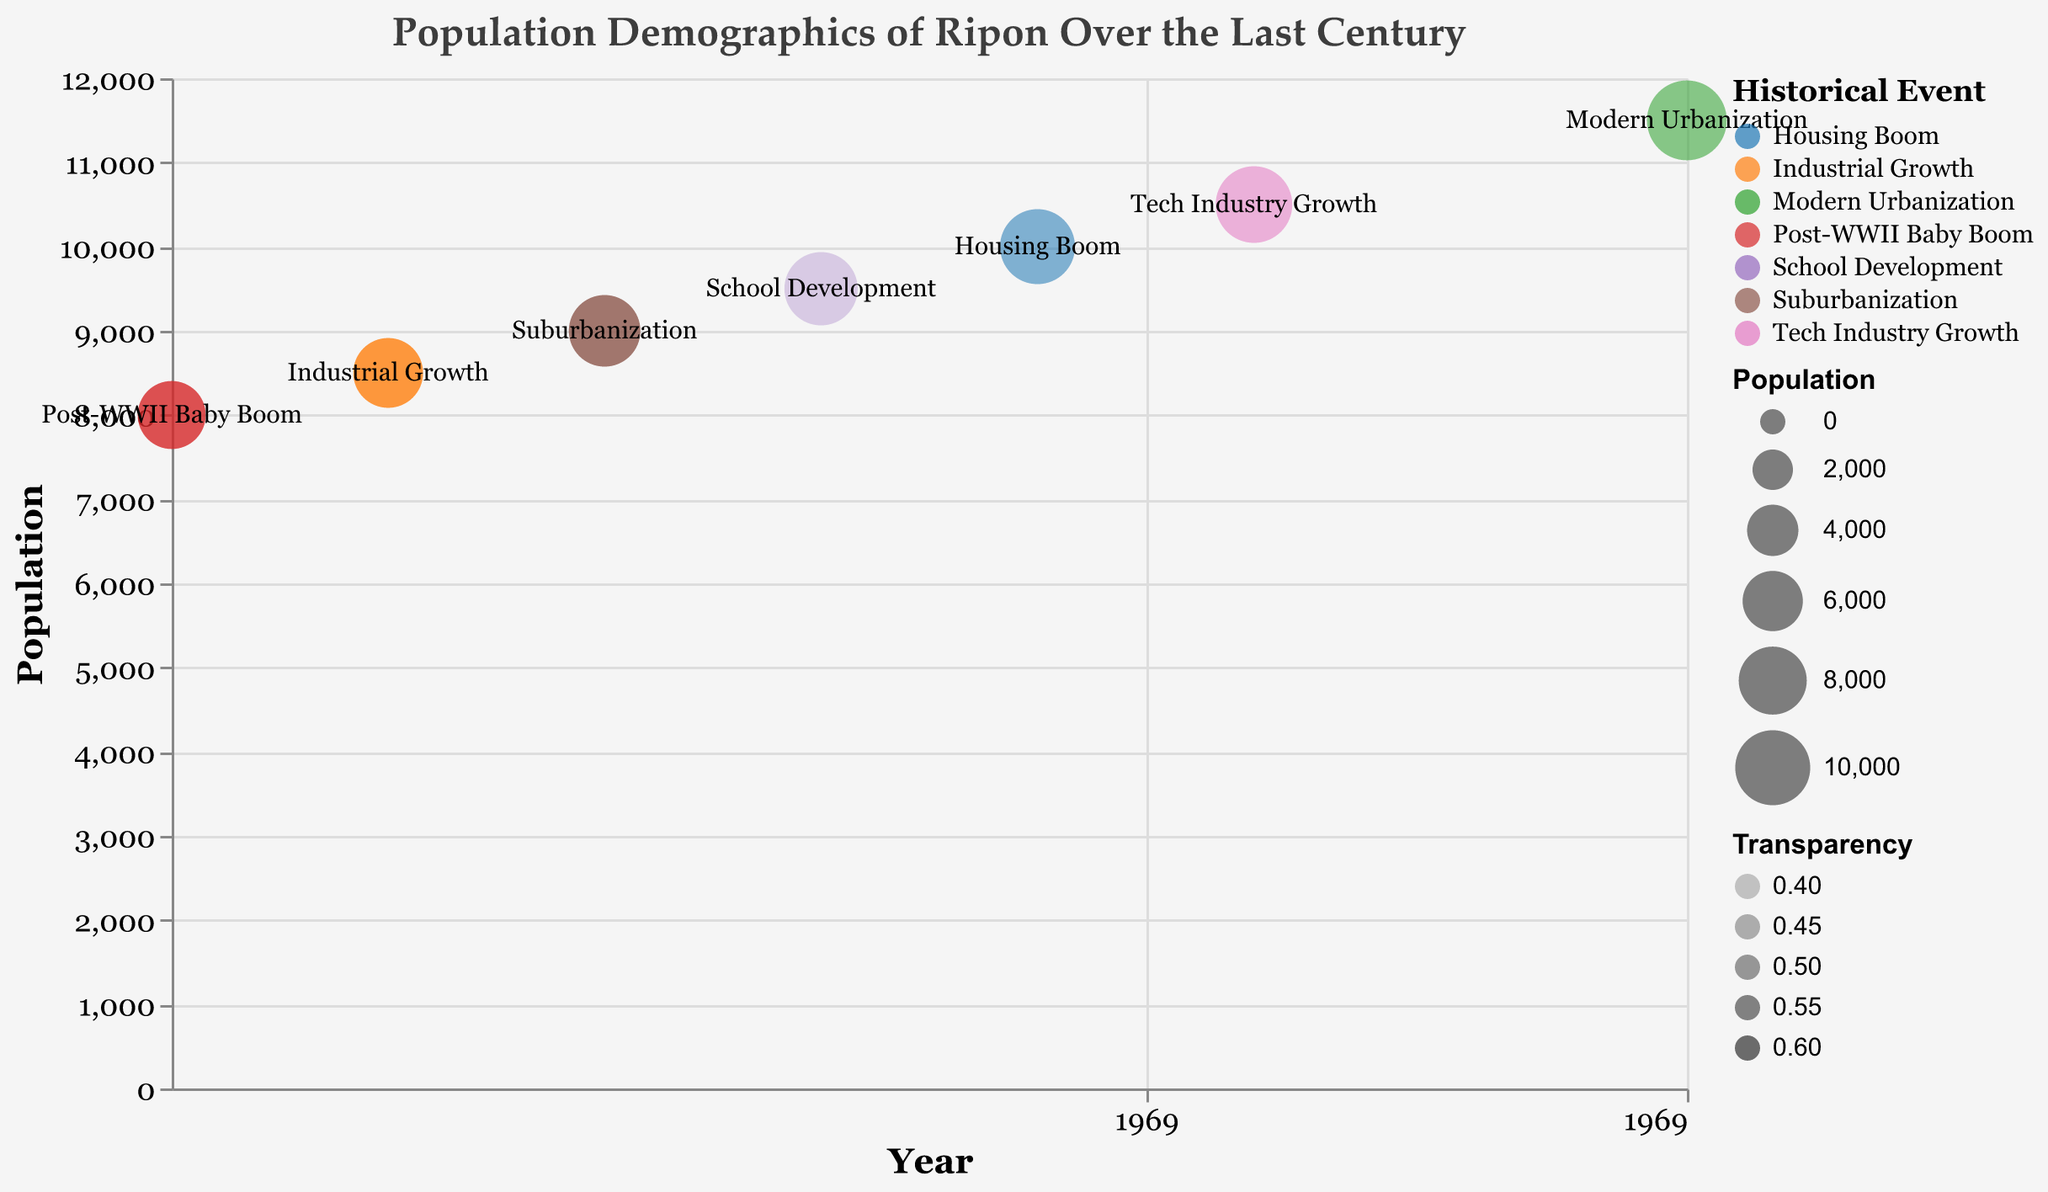What's the title of the figure? The title is displayed at the top of the figure in large, bold text. It reads "Population Demographics of Ripon Over the Last Century."
Answer: Population Demographics of Ripon Over the Last Century Which event had the population at 8500? By locating the population value of 8500 on the y-axis and tracing it to the corresponding bubble in the plot, we find the label "Industrial Growth."
Answer: Industrial Growth What is the population increase between 1950 and 1960? First, identify the population in 1950 (8000) and the population in 1960 (8500). Then, subtract the 1950 population from the 1960 population: 8500 - 8000 = 500.
Answer: 500 Which event has the highest opacity? Check the transparency values associated with each event. The lower the transparency value, the higher the opacity. "School Development" has the lowest transparency value (0.4).
Answer: School Development What was the population during the Post-WWII Baby Boom? Locate the bubble labeled "Post-WWII Baby Boom" and read its associated y-axis value. The population is 8000.
Answer: 8000 How much did the population grow from 1980 to 2020? Identify the population in 1980 (9500) and the population in 2020 (11500). Subtract the 1980 population from the 2020 population: 11500 - 9500 = 2000.
Answer: 2000 Which historical event corresponds to the population at 10000? Trace the y-axis value of 10000 to its corresponding bubble and read the label, which is "Housing Boom."
Answer: Housing Boom Which event had the smallest population increase from the previous event? Calculate the differences between consecutive population values: 1960-1950 (500), 1970-1960 (500), 1980-1970 (500), 1990-1980 (500), 2000-1990 (500), 2020-2000 (1000). All except 2020-2000 had the same increase of 500.
Answer: All increases except 2020-2000 are the same Which event corresponds to the highest population in the dataset? The highest y-axis value is at 11500, corresponding to the event “Modern Urbanization.”
Answer: Modern Urbanization 